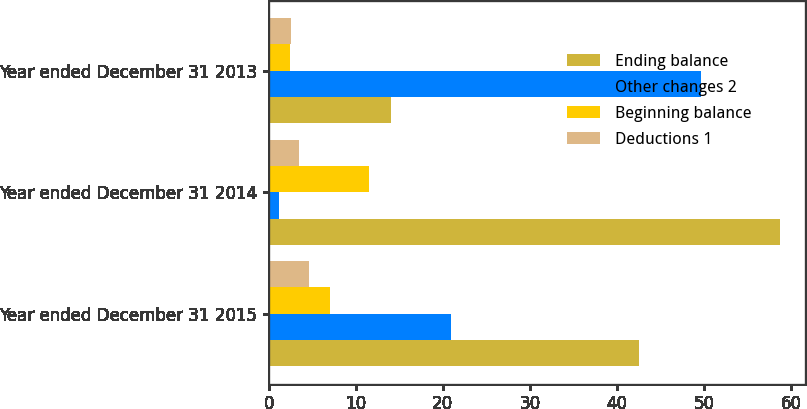Convert chart. <chart><loc_0><loc_0><loc_500><loc_500><stacked_bar_chart><ecel><fcel>Year ended December 31 2015<fcel>Year ended December 31 2014<fcel>Year ended December 31 2013<nl><fcel>Ending balance<fcel>42.5<fcel>58.7<fcel>14<nl><fcel>Other changes 2<fcel>21<fcel>1.2<fcel>49.7<nl><fcel>Beginning balance<fcel>7.1<fcel>11.5<fcel>2.4<nl><fcel>Deductions 1<fcel>4.6<fcel>3.5<fcel>2.6<nl></chart> 